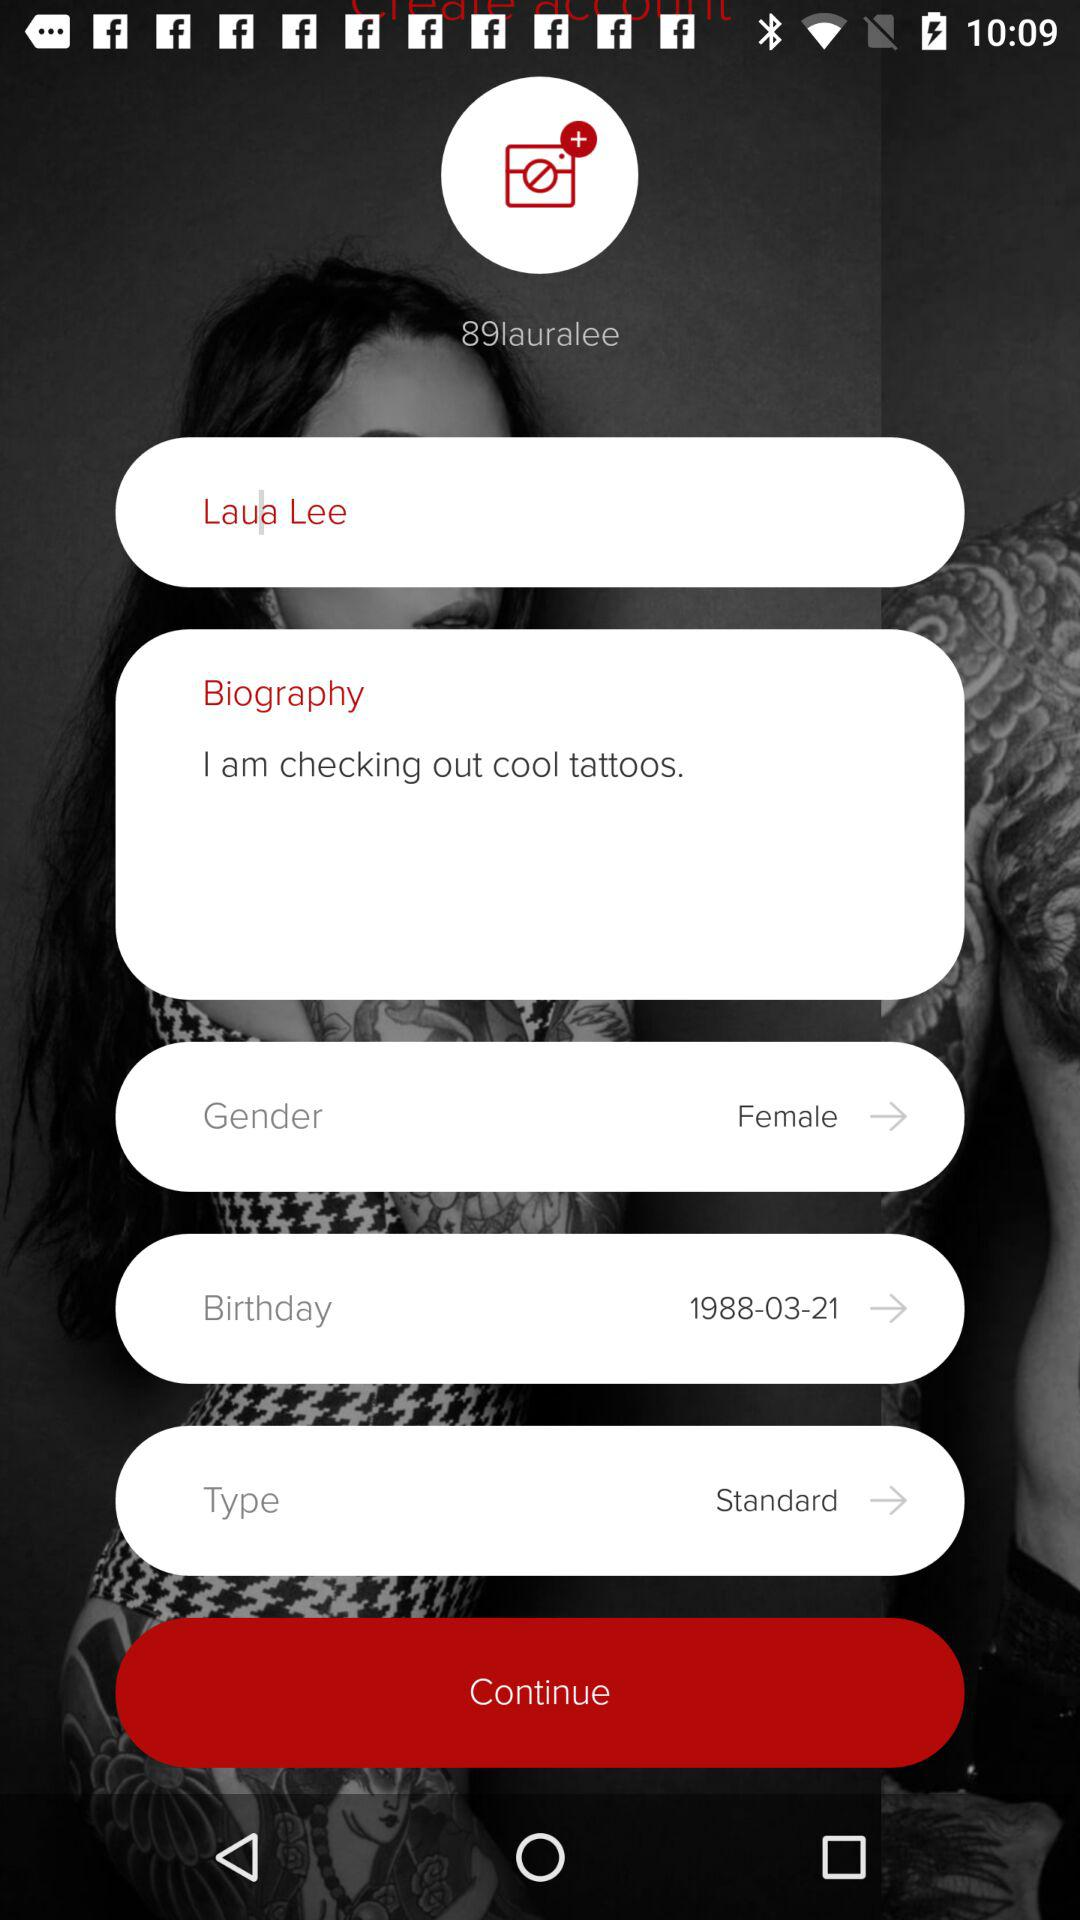What is the birth date? The birth date is "1988-03-21". 